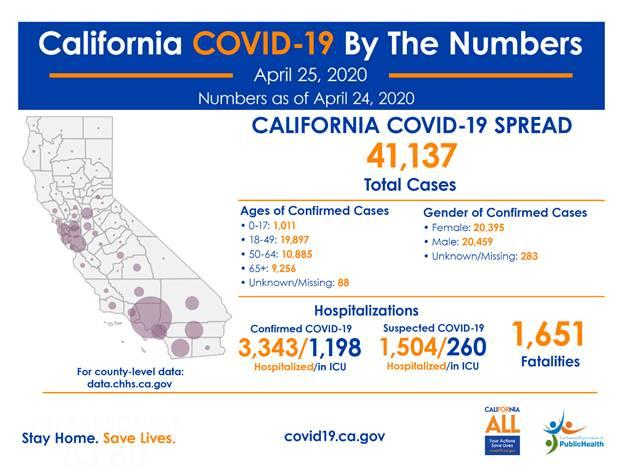Draw attention to some important aspects in this diagram. In ICU, the difference between confirmed and suspected cases refers to the certainty of a patient's illness, with confirmed cases having a higher degree of certainty and suspected cases having a lower degree of certainty. The age group most commonly associated with cases is 18-49 years old. There are a total of 3,1793 confirmed cases of the disease, where the age of the affected individuals is below 65 years old. The majority of cases belong to the male gender group. There are a total of 2,0908 confirmed cases of the disease, where the age of the affected individuals is below 50. 